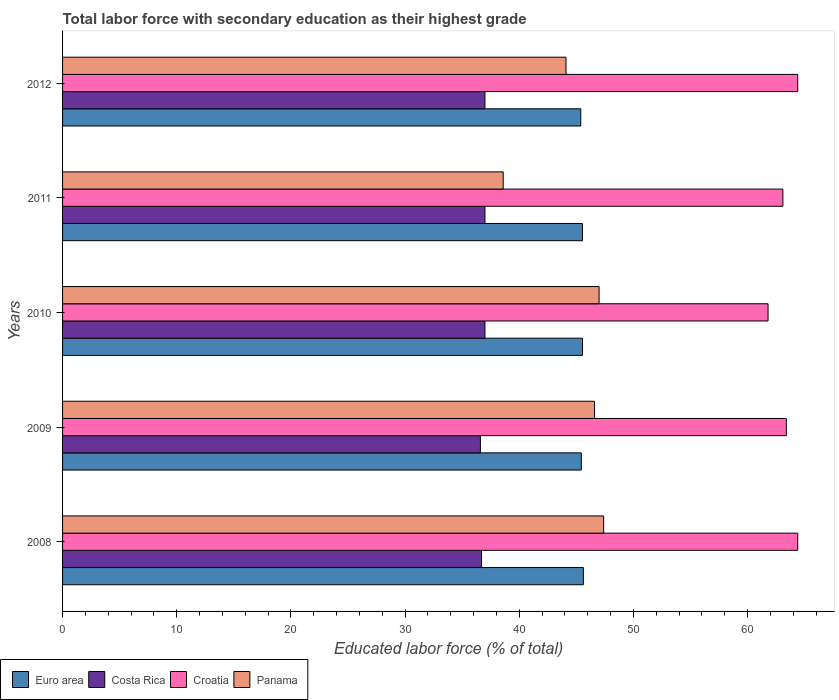How many groups of bars are there?
Offer a very short reply. 5. Are the number of bars per tick equal to the number of legend labels?
Offer a terse response. Yes. Are the number of bars on each tick of the Y-axis equal?
Ensure brevity in your answer.  Yes. How many bars are there on the 1st tick from the bottom?
Keep it short and to the point. 4. What is the label of the 4th group of bars from the top?
Your response must be concise. 2009. In how many cases, is the number of bars for a given year not equal to the number of legend labels?
Your answer should be very brief. 0. What is the percentage of total labor force with primary education in Croatia in 2011?
Provide a succinct answer. 63.1. Across all years, what is the maximum percentage of total labor force with primary education in Euro area?
Give a very brief answer. 45.62. Across all years, what is the minimum percentage of total labor force with primary education in Euro area?
Your answer should be compact. 45.39. In which year was the percentage of total labor force with primary education in Panama maximum?
Provide a succinct answer. 2008. What is the total percentage of total labor force with primary education in Panama in the graph?
Keep it short and to the point. 223.7. What is the difference between the percentage of total labor force with primary education in Croatia in 2009 and that in 2011?
Make the answer very short. 0.3. What is the difference between the percentage of total labor force with primary education in Costa Rica in 2009 and the percentage of total labor force with primary education in Euro area in 2011?
Provide a succinct answer. -8.94. What is the average percentage of total labor force with primary education in Croatia per year?
Give a very brief answer. 63.42. In the year 2008, what is the difference between the percentage of total labor force with primary education in Panama and percentage of total labor force with primary education in Croatia?
Keep it short and to the point. -17. What is the ratio of the percentage of total labor force with primary education in Euro area in 2009 to that in 2012?
Offer a very short reply. 1. What is the difference between the highest and the second highest percentage of total labor force with primary education in Euro area?
Provide a succinct answer. 0.07. What is the difference between the highest and the lowest percentage of total labor force with primary education in Panama?
Provide a short and direct response. 8.8. In how many years, is the percentage of total labor force with primary education in Costa Rica greater than the average percentage of total labor force with primary education in Costa Rica taken over all years?
Offer a terse response. 3. Is the sum of the percentage of total labor force with primary education in Euro area in 2011 and 2012 greater than the maximum percentage of total labor force with primary education in Costa Rica across all years?
Provide a succinct answer. Yes. What does the 3rd bar from the top in 2008 represents?
Provide a succinct answer. Costa Rica. What is the difference between two consecutive major ticks on the X-axis?
Offer a terse response. 10. Does the graph contain any zero values?
Keep it short and to the point. No. Does the graph contain grids?
Give a very brief answer. No. Where does the legend appear in the graph?
Ensure brevity in your answer.  Bottom left. How are the legend labels stacked?
Provide a succinct answer. Horizontal. What is the title of the graph?
Provide a short and direct response. Total labor force with secondary education as their highest grade. What is the label or title of the X-axis?
Give a very brief answer. Educated labor force (% of total). What is the Educated labor force (% of total) in Euro area in 2008?
Keep it short and to the point. 45.62. What is the Educated labor force (% of total) of Costa Rica in 2008?
Keep it short and to the point. 36.7. What is the Educated labor force (% of total) in Croatia in 2008?
Make the answer very short. 64.4. What is the Educated labor force (% of total) in Panama in 2008?
Keep it short and to the point. 47.4. What is the Educated labor force (% of total) of Euro area in 2009?
Your answer should be very brief. 45.44. What is the Educated labor force (% of total) in Costa Rica in 2009?
Keep it short and to the point. 36.6. What is the Educated labor force (% of total) of Croatia in 2009?
Provide a short and direct response. 63.4. What is the Educated labor force (% of total) of Panama in 2009?
Your answer should be very brief. 46.6. What is the Educated labor force (% of total) in Euro area in 2010?
Keep it short and to the point. 45.55. What is the Educated labor force (% of total) of Croatia in 2010?
Ensure brevity in your answer.  61.8. What is the Educated labor force (% of total) in Euro area in 2011?
Make the answer very short. 45.54. What is the Educated labor force (% of total) of Croatia in 2011?
Keep it short and to the point. 63.1. What is the Educated labor force (% of total) of Panama in 2011?
Keep it short and to the point. 38.6. What is the Educated labor force (% of total) of Euro area in 2012?
Offer a terse response. 45.39. What is the Educated labor force (% of total) in Croatia in 2012?
Your response must be concise. 64.4. What is the Educated labor force (% of total) of Panama in 2012?
Keep it short and to the point. 44.1. Across all years, what is the maximum Educated labor force (% of total) of Euro area?
Provide a succinct answer. 45.62. Across all years, what is the maximum Educated labor force (% of total) of Croatia?
Provide a short and direct response. 64.4. Across all years, what is the maximum Educated labor force (% of total) in Panama?
Provide a succinct answer. 47.4. Across all years, what is the minimum Educated labor force (% of total) of Euro area?
Keep it short and to the point. 45.39. Across all years, what is the minimum Educated labor force (% of total) in Costa Rica?
Offer a terse response. 36.6. Across all years, what is the minimum Educated labor force (% of total) of Croatia?
Provide a succinct answer. 61.8. Across all years, what is the minimum Educated labor force (% of total) in Panama?
Your response must be concise. 38.6. What is the total Educated labor force (% of total) of Euro area in the graph?
Offer a terse response. 227.55. What is the total Educated labor force (% of total) in Costa Rica in the graph?
Keep it short and to the point. 184.3. What is the total Educated labor force (% of total) in Croatia in the graph?
Give a very brief answer. 317.1. What is the total Educated labor force (% of total) in Panama in the graph?
Offer a terse response. 223.7. What is the difference between the Educated labor force (% of total) of Euro area in 2008 and that in 2009?
Ensure brevity in your answer.  0.18. What is the difference between the Educated labor force (% of total) in Costa Rica in 2008 and that in 2009?
Provide a succinct answer. 0.1. What is the difference between the Educated labor force (% of total) in Croatia in 2008 and that in 2009?
Give a very brief answer. 1. What is the difference between the Educated labor force (% of total) of Euro area in 2008 and that in 2010?
Offer a very short reply. 0.07. What is the difference between the Educated labor force (% of total) of Panama in 2008 and that in 2010?
Make the answer very short. 0.4. What is the difference between the Educated labor force (% of total) of Euro area in 2008 and that in 2011?
Your response must be concise. 0.08. What is the difference between the Educated labor force (% of total) in Croatia in 2008 and that in 2011?
Your answer should be compact. 1.3. What is the difference between the Educated labor force (% of total) of Panama in 2008 and that in 2011?
Provide a short and direct response. 8.8. What is the difference between the Educated labor force (% of total) of Euro area in 2008 and that in 2012?
Provide a short and direct response. 0.23. What is the difference between the Educated labor force (% of total) of Croatia in 2008 and that in 2012?
Make the answer very short. 0. What is the difference between the Educated labor force (% of total) in Euro area in 2009 and that in 2010?
Keep it short and to the point. -0.11. What is the difference between the Educated labor force (% of total) in Costa Rica in 2009 and that in 2010?
Ensure brevity in your answer.  -0.4. What is the difference between the Educated labor force (% of total) of Panama in 2009 and that in 2010?
Your answer should be very brief. -0.4. What is the difference between the Educated labor force (% of total) of Euro area in 2009 and that in 2011?
Keep it short and to the point. -0.1. What is the difference between the Educated labor force (% of total) of Croatia in 2009 and that in 2011?
Your response must be concise. 0.3. What is the difference between the Educated labor force (% of total) in Panama in 2009 and that in 2011?
Your answer should be very brief. 8. What is the difference between the Educated labor force (% of total) in Euro area in 2009 and that in 2012?
Your answer should be very brief. 0.05. What is the difference between the Educated labor force (% of total) in Euro area in 2010 and that in 2011?
Provide a succinct answer. 0.01. What is the difference between the Educated labor force (% of total) in Euro area in 2010 and that in 2012?
Your answer should be compact. 0.15. What is the difference between the Educated labor force (% of total) of Croatia in 2010 and that in 2012?
Make the answer very short. -2.6. What is the difference between the Educated labor force (% of total) in Euro area in 2011 and that in 2012?
Provide a short and direct response. 0.15. What is the difference between the Educated labor force (% of total) of Euro area in 2008 and the Educated labor force (% of total) of Costa Rica in 2009?
Offer a very short reply. 9.02. What is the difference between the Educated labor force (% of total) in Euro area in 2008 and the Educated labor force (% of total) in Croatia in 2009?
Provide a short and direct response. -17.78. What is the difference between the Educated labor force (% of total) of Euro area in 2008 and the Educated labor force (% of total) of Panama in 2009?
Provide a short and direct response. -0.98. What is the difference between the Educated labor force (% of total) in Costa Rica in 2008 and the Educated labor force (% of total) in Croatia in 2009?
Keep it short and to the point. -26.7. What is the difference between the Educated labor force (% of total) in Euro area in 2008 and the Educated labor force (% of total) in Costa Rica in 2010?
Your answer should be very brief. 8.62. What is the difference between the Educated labor force (% of total) in Euro area in 2008 and the Educated labor force (% of total) in Croatia in 2010?
Ensure brevity in your answer.  -16.18. What is the difference between the Educated labor force (% of total) of Euro area in 2008 and the Educated labor force (% of total) of Panama in 2010?
Provide a short and direct response. -1.38. What is the difference between the Educated labor force (% of total) of Costa Rica in 2008 and the Educated labor force (% of total) of Croatia in 2010?
Provide a short and direct response. -25.1. What is the difference between the Educated labor force (% of total) of Croatia in 2008 and the Educated labor force (% of total) of Panama in 2010?
Offer a very short reply. 17.4. What is the difference between the Educated labor force (% of total) in Euro area in 2008 and the Educated labor force (% of total) in Costa Rica in 2011?
Offer a very short reply. 8.62. What is the difference between the Educated labor force (% of total) in Euro area in 2008 and the Educated labor force (% of total) in Croatia in 2011?
Your response must be concise. -17.48. What is the difference between the Educated labor force (% of total) of Euro area in 2008 and the Educated labor force (% of total) of Panama in 2011?
Make the answer very short. 7.02. What is the difference between the Educated labor force (% of total) in Costa Rica in 2008 and the Educated labor force (% of total) in Croatia in 2011?
Make the answer very short. -26.4. What is the difference between the Educated labor force (% of total) in Croatia in 2008 and the Educated labor force (% of total) in Panama in 2011?
Provide a succinct answer. 25.8. What is the difference between the Educated labor force (% of total) in Euro area in 2008 and the Educated labor force (% of total) in Costa Rica in 2012?
Offer a terse response. 8.62. What is the difference between the Educated labor force (% of total) in Euro area in 2008 and the Educated labor force (% of total) in Croatia in 2012?
Your response must be concise. -18.78. What is the difference between the Educated labor force (% of total) in Euro area in 2008 and the Educated labor force (% of total) in Panama in 2012?
Offer a terse response. 1.52. What is the difference between the Educated labor force (% of total) of Costa Rica in 2008 and the Educated labor force (% of total) of Croatia in 2012?
Make the answer very short. -27.7. What is the difference between the Educated labor force (% of total) of Costa Rica in 2008 and the Educated labor force (% of total) of Panama in 2012?
Your answer should be very brief. -7.4. What is the difference between the Educated labor force (% of total) in Croatia in 2008 and the Educated labor force (% of total) in Panama in 2012?
Ensure brevity in your answer.  20.3. What is the difference between the Educated labor force (% of total) of Euro area in 2009 and the Educated labor force (% of total) of Costa Rica in 2010?
Provide a succinct answer. 8.44. What is the difference between the Educated labor force (% of total) of Euro area in 2009 and the Educated labor force (% of total) of Croatia in 2010?
Keep it short and to the point. -16.36. What is the difference between the Educated labor force (% of total) of Euro area in 2009 and the Educated labor force (% of total) of Panama in 2010?
Provide a short and direct response. -1.56. What is the difference between the Educated labor force (% of total) in Costa Rica in 2009 and the Educated labor force (% of total) in Croatia in 2010?
Ensure brevity in your answer.  -25.2. What is the difference between the Educated labor force (% of total) in Croatia in 2009 and the Educated labor force (% of total) in Panama in 2010?
Make the answer very short. 16.4. What is the difference between the Educated labor force (% of total) of Euro area in 2009 and the Educated labor force (% of total) of Costa Rica in 2011?
Ensure brevity in your answer.  8.44. What is the difference between the Educated labor force (% of total) in Euro area in 2009 and the Educated labor force (% of total) in Croatia in 2011?
Offer a very short reply. -17.66. What is the difference between the Educated labor force (% of total) in Euro area in 2009 and the Educated labor force (% of total) in Panama in 2011?
Your response must be concise. 6.84. What is the difference between the Educated labor force (% of total) of Costa Rica in 2009 and the Educated labor force (% of total) of Croatia in 2011?
Keep it short and to the point. -26.5. What is the difference between the Educated labor force (% of total) in Costa Rica in 2009 and the Educated labor force (% of total) in Panama in 2011?
Offer a terse response. -2. What is the difference between the Educated labor force (% of total) in Croatia in 2009 and the Educated labor force (% of total) in Panama in 2011?
Your response must be concise. 24.8. What is the difference between the Educated labor force (% of total) in Euro area in 2009 and the Educated labor force (% of total) in Costa Rica in 2012?
Your answer should be very brief. 8.44. What is the difference between the Educated labor force (% of total) of Euro area in 2009 and the Educated labor force (% of total) of Croatia in 2012?
Provide a succinct answer. -18.96. What is the difference between the Educated labor force (% of total) in Euro area in 2009 and the Educated labor force (% of total) in Panama in 2012?
Ensure brevity in your answer.  1.34. What is the difference between the Educated labor force (% of total) in Costa Rica in 2009 and the Educated labor force (% of total) in Croatia in 2012?
Your answer should be compact. -27.8. What is the difference between the Educated labor force (% of total) of Croatia in 2009 and the Educated labor force (% of total) of Panama in 2012?
Provide a short and direct response. 19.3. What is the difference between the Educated labor force (% of total) in Euro area in 2010 and the Educated labor force (% of total) in Costa Rica in 2011?
Offer a very short reply. 8.55. What is the difference between the Educated labor force (% of total) of Euro area in 2010 and the Educated labor force (% of total) of Croatia in 2011?
Keep it short and to the point. -17.55. What is the difference between the Educated labor force (% of total) in Euro area in 2010 and the Educated labor force (% of total) in Panama in 2011?
Keep it short and to the point. 6.95. What is the difference between the Educated labor force (% of total) of Costa Rica in 2010 and the Educated labor force (% of total) of Croatia in 2011?
Offer a terse response. -26.1. What is the difference between the Educated labor force (% of total) of Costa Rica in 2010 and the Educated labor force (% of total) of Panama in 2011?
Keep it short and to the point. -1.6. What is the difference between the Educated labor force (% of total) in Croatia in 2010 and the Educated labor force (% of total) in Panama in 2011?
Keep it short and to the point. 23.2. What is the difference between the Educated labor force (% of total) in Euro area in 2010 and the Educated labor force (% of total) in Costa Rica in 2012?
Your response must be concise. 8.55. What is the difference between the Educated labor force (% of total) of Euro area in 2010 and the Educated labor force (% of total) of Croatia in 2012?
Keep it short and to the point. -18.85. What is the difference between the Educated labor force (% of total) of Euro area in 2010 and the Educated labor force (% of total) of Panama in 2012?
Keep it short and to the point. 1.45. What is the difference between the Educated labor force (% of total) of Costa Rica in 2010 and the Educated labor force (% of total) of Croatia in 2012?
Provide a short and direct response. -27.4. What is the difference between the Educated labor force (% of total) in Croatia in 2010 and the Educated labor force (% of total) in Panama in 2012?
Ensure brevity in your answer.  17.7. What is the difference between the Educated labor force (% of total) of Euro area in 2011 and the Educated labor force (% of total) of Costa Rica in 2012?
Ensure brevity in your answer.  8.54. What is the difference between the Educated labor force (% of total) of Euro area in 2011 and the Educated labor force (% of total) of Croatia in 2012?
Your response must be concise. -18.86. What is the difference between the Educated labor force (% of total) in Euro area in 2011 and the Educated labor force (% of total) in Panama in 2012?
Keep it short and to the point. 1.44. What is the difference between the Educated labor force (% of total) in Costa Rica in 2011 and the Educated labor force (% of total) in Croatia in 2012?
Provide a short and direct response. -27.4. What is the difference between the Educated labor force (% of total) in Costa Rica in 2011 and the Educated labor force (% of total) in Panama in 2012?
Provide a short and direct response. -7.1. What is the average Educated labor force (% of total) in Euro area per year?
Your answer should be very brief. 45.51. What is the average Educated labor force (% of total) in Costa Rica per year?
Provide a succinct answer. 36.86. What is the average Educated labor force (% of total) in Croatia per year?
Offer a terse response. 63.42. What is the average Educated labor force (% of total) in Panama per year?
Ensure brevity in your answer.  44.74. In the year 2008, what is the difference between the Educated labor force (% of total) of Euro area and Educated labor force (% of total) of Costa Rica?
Give a very brief answer. 8.92. In the year 2008, what is the difference between the Educated labor force (% of total) in Euro area and Educated labor force (% of total) in Croatia?
Offer a very short reply. -18.78. In the year 2008, what is the difference between the Educated labor force (% of total) of Euro area and Educated labor force (% of total) of Panama?
Offer a terse response. -1.78. In the year 2008, what is the difference between the Educated labor force (% of total) in Costa Rica and Educated labor force (% of total) in Croatia?
Your response must be concise. -27.7. In the year 2008, what is the difference between the Educated labor force (% of total) in Costa Rica and Educated labor force (% of total) in Panama?
Your answer should be very brief. -10.7. In the year 2008, what is the difference between the Educated labor force (% of total) of Croatia and Educated labor force (% of total) of Panama?
Ensure brevity in your answer.  17. In the year 2009, what is the difference between the Educated labor force (% of total) of Euro area and Educated labor force (% of total) of Costa Rica?
Make the answer very short. 8.84. In the year 2009, what is the difference between the Educated labor force (% of total) in Euro area and Educated labor force (% of total) in Croatia?
Provide a succinct answer. -17.96. In the year 2009, what is the difference between the Educated labor force (% of total) of Euro area and Educated labor force (% of total) of Panama?
Give a very brief answer. -1.16. In the year 2009, what is the difference between the Educated labor force (% of total) in Costa Rica and Educated labor force (% of total) in Croatia?
Offer a very short reply. -26.8. In the year 2009, what is the difference between the Educated labor force (% of total) in Costa Rica and Educated labor force (% of total) in Panama?
Keep it short and to the point. -10. In the year 2009, what is the difference between the Educated labor force (% of total) in Croatia and Educated labor force (% of total) in Panama?
Your response must be concise. 16.8. In the year 2010, what is the difference between the Educated labor force (% of total) in Euro area and Educated labor force (% of total) in Costa Rica?
Provide a succinct answer. 8.55. In the year 2010, what is the difference between the Educated labor force (% of total) of Euro area and Educated labor force (% of total) of Croatia?
Provide a succinct answer. -16.25. In the year 2010, what is the difference between the Educated labor force (% of total) in Euro area and Educated labor force (% of total) in Panama?
Offer a terse response. -1.45. In the year 2010, what is the difference between the Educated labor force (% of total) of Costa Rica and Educated labor force (% of total) of Croatia?
Ensure brevity in your answer.  -24.8. In the year 2010, what is the difference between the Educated labor force (% of total) of Croatia and Educated labor force (% of total) of Panama?
Make the answer very short. 14.8. In the year 2011, what is the difference between the Educated labor force (% of total) in Euro area and Educated labor force (% of total) in Costa Rica?
Provide a short and direct response. 8.54. In the year 2011, what is the difference between the Educated labor force (% of total) in Euro area and Educated labor force (% of total) in Croatia?
Your answer should be compact. -17.56. In the year 2011, what is the difference between the Educated labor force (% of total) of Euro area and Educated labor force (% of total) of Panama?
Your answer should be compact. 6.94. In the year 2011, what is the difference between the Educated labor force (% of total) in Costa Rica and Educated labor force (% of total) in Croatia?
Ensure brevity in your answer.  -26.1. In the year 2011, what is the difference between the Educated labor force (% of total) of Costa Rica and Educated labor force (% of total) of Panama?
Provide a succinct answer. -1.6. In the year 2011, what is the difference between the Educated labor force (% of total) of Croatia and Educated labor force (% of total) of Panama?
Provide a succinct answer. 24.5. In the year 2012, what is the difference between the Educated labor force (% of total) of Euro area and Educated labor force (% of total) of Costa Rica?
Provide a short and direct response. 8.39. In the year 2012, what is the difference between the Educated labor force (% of total) of Euro area and Educated labor force (% of total) of Croatia?
Your response must be concise. -19.01. In the year 2012, what is the difference between the Educated labor force (% of total) in Euro area and Educated labor force (% of total) in Panama?
Your response must be concise. 1.29. In the year 2012, what is the difference between the Educated labor force (% of total) of Costa Rica and Educated labor force (% of total) of Croatia?
Offer a very short reply. -27.4. In the year 2012, what is the difference between the Educated labor force (% of total) in Croatia and Educated labor force (% of total) in Panama?
Make the answer very short. 20.3. What is the ratio of the Educated labor force (% of total) of Croatia in 2008 to that in 2009?
Offer a very short reply. 1.02. What is the ratio of the Educated labor force (% of total) of Panama in 2008 to that in 2009?
Your answer should be compact. 1.02. What is the ratio of the Educated labor force (% of total) of Croatia in 2008 to that in 2010?
Your answer should be very brief. 1.04. What is the ratio of the Educated labor force (% of total) of Panama in 2008 to that in 2010?
Ensure brevity in your answer.  1.01. What is the ratio of the Educated labor force (% of total) in Euro area in 2008 to that in 2011?
Offer a terse response. 1. What is the ratio of the Educated labor force (% of total) in Croatia in 2008 to that in 2011?
Your response must be concise. 1.02. What is the ratio of the Educated labor force (% of total) of Panama in 2008 to that in 2011?
Ensure brevity in your answer.  1.23. What is the ratio of the Educated labor force (% of total) of Euro area in 2008 to that in 2012?
Offer a terse response. 1. What is the ratio of the Educated labor force (% of total) of Croatia in 2008 to that in 2012?
Offer a very short reply. 1. What is the ratio of the Educated labor force (% of total) of Panama in 2008 to that in 2012?
Give a very brief answer. 1.07. What is the ratio of the Educated labor force (% of total) of Euro area in 2009 to that in 2010?
Provide a short and direct response. 1. What is the ratio of the Educated labor force (% of total) of Croatia in 2009 to that in 2010?
Provide a short and direct response. 1.03. What is the ratio of the Educated labor force (% of total) of Euro area in 2009 to that in 2011?
Your answer should be compact. 1. What is the ratio of the Educated labor force (% of total) in Panama in 2009 to that in 2011?
Provide a succinct answer. 1.21. What is the ratio of the Educated labor force (% of total) in Euro area in 2009 to that in 2012?
Provide a short and direct response. 1. What is the ratio of the Educated labor force (% of total) in Croatia in 2009 to that in 2012?
Give a very brief answer. 0.98. What is the ratio of the Educated labor force (% of total) of Panama in 2009 to that in 2012?
Your response must be concise. 1.06. What is the ratio of the Educated labor force (% of total) of Costa Rica in 2010 to that in 2011?
Your answer should be compact. 1. What is the ratio of the Educated labor force (% of total) in Croatia in 2010 to that in 2011?
Provide a short and direct response. 0.98. What is the ratio of the Educated labor force (% of total) in Panama in 2010 to that in 2011?
Ensure brevity in your answer.  1.22. What is the ratio of the Educated labor force (% of total) of Costa Rica in 2010 to that in 2012?
Provide a short and direct response. 1. What is the ratio of the Educated labor force (% of total) of Croatia in 2010 to that in 2012?
Your answer should be very brief. 0.96. What is the ratio of the Educated labor force (% of total) in Panama in 2010 to that in 2012?
Offer a very short reply. 1.07. What is the ratio of the Educated labor force (% of total) of Euro area in 2011 to that in 2012?
Keep it short and to the point. 1. What is the ratio of the Educated labor force (% of total) of Croatia in 2011 to that in 2012?
Offer a very short reply. 0.98. What is the ratio of the Educated labor force (% of total) in Panama in 2011 to that in 2012?
Provide a short and direct response. 0.88. What is the difference between the highest and the second highest Educated labor force (% of total) in Euro area?
Provide a succinct answer. 0.07. What is the difference between the highest and the lowest Educated labor force (% of total) of Euro area?
Give a very brief answer. 0.23. What is the difference between the highest and the lowest Educated labor force (% of total) of Costa Rica?
Ensure brevity in your answer.  0.4. What is the difference between the highest and the lowest Educated labor force (% of total) in Croatia?
Make the answer very short. 2.6. 